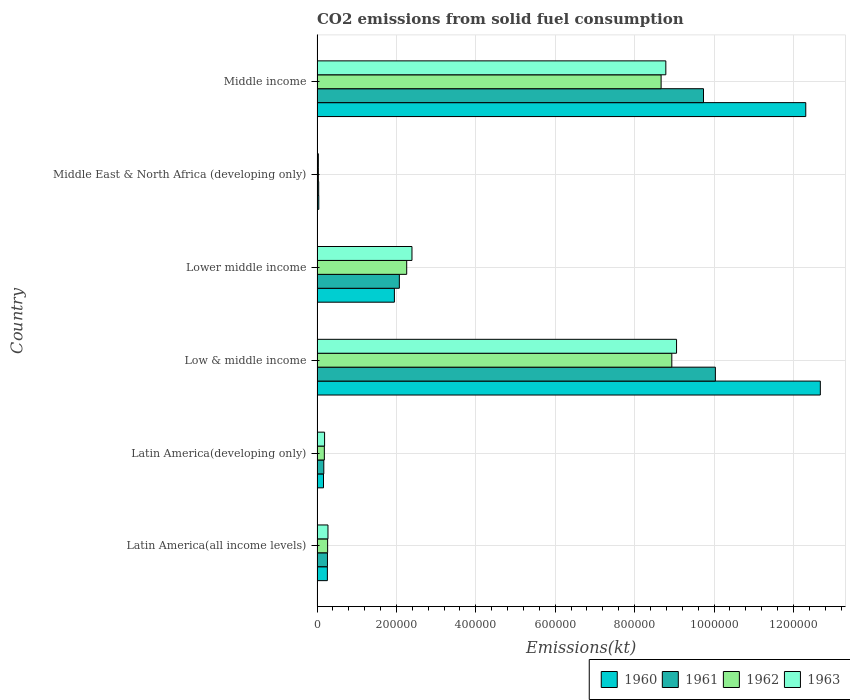Are the number of bars per tick equal to the number of legend labels?
Provide a succinct answer. Yes. Are the number of bars on each tick of the Y-axis equal?
Give a very brief answer. Yes. How many bars are there on the 5th tick from the top?
Keep it short and to the point. 4. How many bars are there on the 3rd tick from the bottom?
Provide a short and direct response. 4. What is the label of the 5th group of bars from the top?
Offer a terse response. Latin America(developing only). What is the amount of CO2 emitted in 1963 in Middle income?
Keep it short and to the point. 8.79e+05. Across all countries, what is the maximum amount of CO2 emitted in 1961?
Offer a terse response. 1.00e+06. Across all countries, what is the minimum amount of CO2 emitted in 1960?
Ensure brevity in your answer.  4356.8. In which country was the amount of CO2 emitted in 1962 maximum?
Make the answer very short. Low & middle income. In which country was the amount of CO2 emitted in 1962 minimum?
Your response must be concise. Middle East & North Africa (developing only). What is the total amount of CO2 emitted in 1960 in the graph?
Make the answer very short. 2.74e+06. What is the difference between the amount of CO2 emitted in 1960 in Low & middle income and that in Middle income?
Provide a short and direct response. 3.67e+04. What is the difference between the amount of CO2 emitted in 1961 in Latin America(developing only) and the amount of CO2 emitted in 1963 in Low & middle income?
Your answer should be compact. -8.89e+05. What is the average amount of CO2 emitted in 1961 per country?
Offer a terse response. 3.72e+05. What is the difference between the amount of CO2 emitted in 1961 and amount of CO2 emitted in 1963 in Middle East & North Africa (developing only)?
Keep it short and to the point. 800.71. What is the ratio of the amount of CO2 emitted in 1963 in Latin America(developing only) to that in Low & middle income?
Your answer should be very brief. 0.02. Is the amount of CO2 emitted in 1960 in Latin America(all income levels) less than that in Latin America(developing only)?
Offer a very short reply. No. Is the difference between the amount of CO2 emitted in 1961 in Latin America(all income levels) and Latin America(developing only) greater than the difference between the amount of CO2 emitted in 1963 in Latin America(all income levels) and Latin America(developing only)?
Your answer should be compact. Yes. What is the difference between the highest and the second highest amount of CO2 emitted in 1963?
Your response must be concise. 2.70e+04. What is the difference between the highest and the lowest amount of CO2 emitted in 1962?
Provide a short and direct response. 8.90e+05. What does the 4th bar from the top in Lower middle income represents?
Your answer should be very brief. 1960. What does the 4th bar from the bottom in Low & middle income represents?
Your response must be concise. 1963. Is it the case that in every country, the sum of the amount of CO2 emitted in 1963 and amount of CO2 emitted in 1961 is greater than the amount of CO2 emitted in 1960?
Give a very brief answer. Yes. Are the values on the major ticks of X-axis written in scientific E-notation?
Your answer should be very brief. No. Does the graph contain any zero values?
Provide a short and direct response. No. Does the graph contain grids?
Your answer should be compact. Yes. What is the title of the graph?
Give a very brief answer. CO2 emissions from solid fuel consumption. Does "2012" appear as one of the legend labels in the graph?
Ensure brevity in your answer.  No. What is the label or title of the X-axis?
Your answer should be very brief. Emissions(kt). What is the Emissions(kt) of 1960 in Latin America(all income levels)?
Your response must be concise. 2.60e+04. What is the Emissions(kt) in 1961 in Latin America(all income levels)?
Your answer should be very brief. 2.63e+04. What is the Emissions(kt) of 1962 in Latin America(all income levels)?
Give a very brief answer. 2.67e+04. What is the Emissions(kt) of 1963 in Latin America(all income levels)?
Ensure brevity in your answer.  2.75e+04. What is the Emissions(kt) in 1960 in Latin America(developing only)?
Offer a very short reply. 1.62e+04. What is the Emissions(kt) in 1961 in Latin America(developing only)?
Provide a succinct answer. 1.70e+04. What is the Emissions(kt) in 1962 in Latin America(developing only)?
Make the answer very short. 1.83e+04. What is the Emissions(kt) of 1963 in Latin America(developing only)?
Provide a short and direct response. 1.90e+04. What is the Emissions(kt) of 1960 in Low & middle income?
Offer a terse response. 1.27e+06. What is the Emissions(kt) in 1961 in Low & middle income?
Make the answer very short. 1.00e+06. What is the Emissions(kt) in 1962 in Low & middle income?
Provide a succinct answer. 8.94e+05. What is the Emissions(kt) of 1963 in Low & middle income?
Your answer should be compact. 9.06e+05. What is the Emissions(kt) of 1960 in Lower middle income?
Your response must be concise. 1.95e+05. What is the Emissions(kt) of 1961 in Lower middle income?
Provide a short and direct response. 2.07e+05. What is the Emissions(kt) of 1962 in Lower middle income?
Ensure brevity in your answer.  2.26e+05. What is the Emissions(kt) of 1963 in Lower middle income?
Ensure brevity in your answer.  2.39e+05. What is the Emissions(kt) in 1960 in Middle East & North Africa (developing only)?
Make the answer very short. 4356.8. What is the Emissions(kt) in 1961 in Middle East & North Africa (developing only)?
Your response must be concise. 4102.45. What is the Emissions(kt) of 1962 in Middle East & North Africa (developing only)?
Make the answer very short. 3311.16. What is the Emissions(kt) of 1963 in Middle East & North Africa (developing only)?
Give a very brief answer. 3301.74. What is the Emissions(kt) of 1960 in Middle income?
Keep it short and to the point. 1.23e+06. What is the Emissions(kt) of 1961 in Middle income?
Your answer should be compact. 9.74e+05. What is the Emissions(kt) in 1962 in Middle income?
Give a very brief answer. 8.67e+05. What is the Emissions(kt) of 1963 in Middle income?
Offer a terse response. 8.79e+05. Across all countries, what is the maximum Emissions(kt) in 1960?
Make the answer very short. 1.27e+06. Across all countries, what is the maximum Emissions(kt) of 1961?
Provide a succinct answer. 1.00e+06. Across all countries, what is the maximum Emissions(kt) in 1962?
Your answer should be very brief. 8.94e+05. Across all countries, what is the maximum Emissions(kt) in 1963?
Your answer should be very brief. 9.06e+05. Across all countries, what is the minimum Emissions(kt) of 1960?
Make the answer very short. 4356.8. Across all countries, what is the minimum Emissions(kt) in 1961?
Make the answer very short. 4102.45. Across all countries, what is the minimum Emissions(kt) in 1962?
Offer a terse response. 3311.16. Across all countries, what is the minimum Emissions(kt) in 1963?
Your answer should be very brief. 3301.74. What is the total Emissions(kt) of 1960 in the graph?
Provide a short and direct response. 2.74e+06. What is the total Emissions(kt) of 1961 in the graph?
Your answer should be very brief. 2.23e+06. What is the total Emissions(kt) in 1962 in the graph?
Your answer should be very brief. 2.03e+06. What is the total Emissions(kt) of 1963 in the graph?
Your answer should be very brief. 2.07e+06. What is the difference between the Emissions(kt) in 1960 in Latin America(all income levels) and that in Latin America(developing only)?
Your answer should be compact. 9759.8. What is the difference between the Emissions(kt) of 1961 in Latin America(all income levels) and that in Latin America(developing only)?
Make the answer very short. 9282.45. What is the difference between the Emissions(kt) of 1962 in Latin America(all income levels) and that in Latin America(developing only)?
Provide a succinct answer. 8301.83. What is the difference between the Emissions(kt) in 1963 in Latin America(all income levels) and that in Latin America(developing only)?
Give a very brief answer. 8542.91. What is the difference between the Emissions(kt) of 1960 in Latin America(all income levels) and that in Low & middle income?
Ensure brevity in your answer.  -1.24e+06. What is the difference between the Emissions(kt) in 1961 in Latin America(all income levels) and that in Low & middle income?
Offer a very short reply. -9.77e+05. What is the difference between the Emissions(kt) in 1962 in Latin America(all income levels) and that in Low & middle income?
Ensure brevity in your answer.  -8.67e+05. What is the difference between the Emissions(kt) of 1963 in Latin America(all income levels) and that in Low & middle income?
Your response must be concise. -8.78e+05. What is the difference between the Emissions(kt) of 1960 in Latin America(all income levels) and that in Lower middle income?
Offer a terse response. -1.69e+05. What is the difference between the Emissions(kt) of 1961 in Latin America(all income levels) and that in Lower middle income?
Your response must be concise. -1.81e+05. What is the difference between the Emissions(kt) of 1962 in Latin America(all income levels) and that in Lower middle income?
Your answer should be very brief. -1.99e+05. What is the difference between the Emissions(kt) of 1963 in Latin America(all income levels) and that in Lower middle income?
Provide a succinct answer. -2.12e+05. What is the difference between the Emissions(kt) in 1960 in Latin America(all income levels) and that in Middle East & North Africa (developing only)?
Provide a succinct answer. 2.17e+04. What is the difference between the Emissions(kt) in 1961 in Latin America(all income levels) and that in Middle East & North Africa (developing only)?
Your answer should be compact. 2.22e+04. What is the difference between the Emissions(kt) of 1962 in Latin America(all income levels) and that in Middle East & North Africa (developing only)?
Your response must be concise. 2.33e+04. What is the difference between the Emissions(kt) of 1963 in Latin America(all income levels) and that in Middle East & North Africa (developing only)?
Keep it short and to the point. 2.42e+04. What is the difference between the Emissions(kt) in 1960 in Latin America(all income levels) and that in Middle income?
Make the answer very short. -1.21e+06. What is the difference between the Emissions(kt) of 1961 in Latin America(all income levels) and that in Middle income?
Your answer should be very brief. -9.47e+05. What is the difference between the Emissions(kt) of 1962 in Latin America(all income levels) and that in Middle income?
Provide a short and direct response. -8.40e+05. What is the difference between the Emissions(kt) in 1963 in Latin America(all income levels) and that in Middle income?
Provide a short and direct response. -8.51e+05. What is the difference between the Emissions(kt) in 1960 in Latin America(developing only) and that in Low & middle income?
Offer a very short reply. -1.25e+06. What is the difference between the Emissions(kt) of 1961 in Latin America(developing only) and that in Low & middle income?
Offer a terse response. -9.86e+05. What is the difference between the Emissions(kt) of 1962 in Latin America(developing only) and that in Low & middle income?
Offer a terse response. -8.75e+05. What is the difference between the Emissions(kt) of 1963 in Latin America(developing only) and that in Low & middle income?
Offer a very short reply. -8.87e+05. What is the difference between the Emissions(kt) in 1960 in Latin America(developing only) and that in Lower middle income?
Keep it short and to the point. -1.79e+05. What is the difference between the Emissions(kt) in 1961 in Latin America(developing only) and that in Lower middle income?
Offer a very short reply. -1.90e+05. What is the difference between the Emissions(kt) in 1962 in Latin America(developing only) and that in Lower middle income?
Offer a very short reply. -2.08e+05. What is the difference between the Emissions(kt) in 1963 in Latin America(developing only) and that in Lower middle income?
Your response must be concise. -2.20e+05. What is the difference between the Emissions(kt) in 1960 in Latin America(developing only) and that in Middle East & North Africa (developing only)?
Ensure brevity in your answer.  1.19e+04. What is the difference between the Emissions(kt) in 1961 in Latin America(developing only) and that in Middle East & North Africa (developing only)?
Offer a very short reply. 1.29e+04. What is the difference between the Emissions(kt) in 1962 in Latin America(developing only) and that in Middle East & North Africa (developing only)?
Offer a very short reply. 1.50e+04. What is the difference between the Emissions(kt) in 1963 in Latin America(developing only) and that in Middle East & North Africa (developing only)?
Provide a short and direct response. 1.57e+04. What is the difference between the Emissions(kt) of 1960 in Latin America(developing only) and that in Middle income?
Keep it short and to the point. -1.21e+06. What is the difference between the Emissions(kt) of 1961 in Latin America(developing only) and that in Middle income?
Ensure brevity in your answer.  -9.57e+05. What is the difference between the Emissions(kt) of 1962 in Latin America(developing only) and that in Middle income?
Give a very brief answer. -8.48e+05. What is the difference between the Emissions(kt) in 1963 in Latin America(developing only) and that in Middle income?
Keep it short and to the point. -8.60e+05. What is the difference between the Emissions(kt) in 1960 in Low & middle income and that in Lower middle income?
Make the answer very short. 1.07e+06. What is the difference between the Emissions(kt) in 1961 in Low & middle income and that in Lower middle income?
Provide a short and direct response. 7.96e+05. What is the difference between the Emissions(kt) in 1962 in Low & middle income and that in Lower middle income?
Your answer should be very brief. 6.68e+05. What is the difference between the Emissions(kt) in 1963 in Low & middle income and that in Lower middle income?
Ensure brevity in your answer.  6.67e+05. What is the difference between the Emissions(kt) of 1960 in Low & middle income and that in Middle East & North Africa (developing only)?
Make the answer very short. 1.26e+06. What is the difference between the Emissions(kt) of 1961 in Low & middle income and that in Middle East & North Africa (developing only)?
Provide a short and direct response. 9.99e+05. What is the difference between the Emissions(kt) in 1962 in Low & middle income and that in Middle East & North Africa (developing only)?
Provide a short and direct response. 8.90e+05. What is the difference between the Emissions(kt) of 1963 in Low & middle income and that in Middle East & North Africa (developing only)?
Ensure brevity in your answer.  9.02e+05. What is the difference between the Emissions(kt) in 1960 in Low & middle income and that in Middle income?
Keep it short and to the point. 3.67e+04. What is the difference between the Emissions(kt) of 1961 in Low & middle income and that in Middle income?
Provide a succinct answer. 2.99e+04. What is the difference between the Emissions(kt) in 1962 in Low & middle income and that in Middle income?
Keep it short and to the point. 2.70e+04. What is the difference between the Emissions(kt) in 1963 in Low & middle income and that in Middle income?
Provide a short and direct response. 2.70e+04. What is the difference between the Emissions(kt) of 1960 in Lower middle income and that in Middle East & North Africa (developing only)?
Your response must be concise. 1.90e+05. What is the difference between the Emissions(kt) of 1961 in Lower middle income and that in Middle East & North Africa (developing only)?
Give a very brief answer. 2.03e+05. What is the difference between the Emissions(kt) in 1962 in Lower middle income and that in Middle East & North Africa (developing only)?
Provide a short and direct response. 2.23e+05. What is the difference between the Emissions(kt) in 1963 in Lower middle income and that in Middle East & North Africa (developing only)?
Keep it short and to the point. 2.36e+05. What is the difference between the Emissions(kt) of 1960 in Lower middle income and that in Middle income?
Your answer should be compact. -1.04e+06. What is the difference between the Emissions(kt) in 1961 in Lower middle income and that in Middle income?
Give a very brief answer. -7.66e+05. What is the difference between the Emissions(kt) in 1962 in Lower middle income and that in Middle income?
Provide a succinct answer. -6.41e+05. What is the difference between the Emissions(kt) in 1963 in Lower middle income and that in Middle income?
Your answer should be compact. -6.40e+05. What is the difference between the Emissions(kt) in 1960 in Middle East & North Africa (developing only) and that in Middle income?
Your answer should be very brief. -1.23e+06. What is the difference between the Emissions(kt) in 1961 in Middle East & North Africa (developing only) and that in Middle income?
Give a very brief answer. -9.69e+05. What is the difference between the Emissions(kt) of 1962 in Middle East & North Africa (developing only) and that in Middle income?
Ensure brevity in your answer.  -8.63e+05. What is the difference between the Emissions(kt) in 1963 in Middle East & North Africa (developing only) and that in Middle income?
Make the answer very short. -8.75e+05. What is the difference between the Emissions(kt) of 1960 in Latin America(all income levels) and the Emissions(kt) of 1961 in Latin America(developing only)?
Provide a short and direct response. 9031.46. What is the difference between the Emissions(kt) in 1960 in Latin America(all income levels) and the Emissions(kt) in 1962 in Latin America(developing only)?
Give a very brief answer. 7658.68. What is the difference between the Emissions(kt) in 1960 in Latin America(all income levels) and the Emissions(kt) in 1963 in Latin America(developing only)?
Provide a short and direct response. 7040.93. What is the difference between the Emissions(kt) of 1961 in Latin America(all income levels) and the Emissions(kt) of 1962 in Latin America(developing only)?
Make the answer very short. 7909.66. What is the difference between the Emissions(kt) of 1961 in Latin America(all income levels) and the Emissions(kt) of 1963 in Latin America(developing only)?
Your answer should be compact. 7291.91. What is the difference between the Emissions(kt) of 1962 in Latin America(all income levels) and the Emissions(kt) of 1963 in Latin America(developing only)?
Give a very brief answer. 7684.07. What is the difference between the Emissions(kt) in 1960 in Latin America(all income levels) and the Emissions(kt) in 1961 in Low & middle income?
Make the answer very short. -9.77e+05. What is the difference between the Emissions(kt) of 1960 in Latin America(all income levels) and the Emissions(kt) of 1962 in Low & middle income?
Your answer should be very brief. -8.68e+05. What is the difference between the Emissions(kt) in 1960 in Latin America(all income levels) and the Emissions(kt) in 1963 in Low & middle income?
Keep it short and to the point. -8.80e+05. What is the difference between the Emissions(kt) of 1961 in Latin America(all income levels) and the Emissions(kt) of 1962 in Low & middle income?
Ensure brevity in your answer.  -8.67e+05. What is the difference between the Emissions(kt) in 1961 in Latin America(all income levels) and the Emissions(kt) in 1963 in Low & middle income?
Give a very brief answer. -8.79e+05. What is the difference between the Emissions(kt) of 1962 in Latin America(all income levels) and the Emissions(kt) of 1963 in Low & middle income?
Provide a short and direct response. -8.79e+05. What is the difference between the Emissions(kt) in 1960 in Latin America(all income levels) and the Emissions(kt) in 1961 in Lower middle income?
Your answer should be compact. -1.81e+05. What is the difference between the Emissions(kt) of 1960 in Latin America(all income levels) and the Emissions(kt) of 1962 in Lower middle income?
Ensure brevity in your answer.  -2.00e+05. What is the difference between the Emissions(kt) of 1960 in Latin America(all income levels) and the Emissions(kt) of 1963 in Lower middle income?
Provide a succinct answer. -2.13e+05. What is the difference between the Emissions(kt) in 1961 in Latin America(all income levels) and the Emissions(kt) in 1962 in Lower middle income?
Ensure brevity in your answer.  -2.00e+05. What is the difference between the Emissions(kt) in 1961 in Latin America(all income levels) and the Emissions(kt) in 1963 in Lower middle income?
Give a very brief answer. -2.13e+05. What is the difference between the Emissions(kt) of 1962 in Latin America(all income levels) and the Emissions(kt) of 1963 in Lower middle income?
Ensure brevity in your answer.  -2.12e+05. What is the difference between the Emissions(kt) of 1960 in Latin America(all income levels) and the Emissions(kt) of 1961 in Middle East & North Africa (developing only)?
Your answer should be compact. 2.19e+04. What is the difference between the Emissions(kt) of 1960 in Latin America(all income levels) and the Emissions(kt) of 1962 in Middle East & North Africa (developing only)?
Provide a short and direct response. 2.27e+04. What is the difference between the Emissions(kt) in 1960 in Latin America(all income levels) and the Emissions(kt) in 1963 in Middle East & North Africa (developing only)?
Make the answer very short. 2.27e+04. What is the difference between the Emissions(kt) of 1961 in Latin America(all income levels) and the Emissions(kt) of 1962 in Middle East & North Africa (developing only)?
Provide a short and direct response. 2.29e+04. What is the difference between the Emissions(kt) in 1961 in Latin America(all income levels) and the Emissions(kt) in 1963 in Middle East & North Africa (developing only)?
Provide a short and direct response. 2.30e+04. What is the difference between the Emissions(kt) of 1962 in Latin America(all income levels) and the Emissions(kt) of 1963 in Middle East & North Africa (developing only)?
Offer a very short reply. 2.33e+04. What is the difference between the Emissions(kt) of 1960 in Latin America(all income levels) and the Emissions(kt) of 1961 in Middle income?
Provide a short and direct response. -9.47e+05. What is the difference between the Emissions(kt) of 1960 in Latin America(all income levels) and the Emissions(kt) of 1962 in Middle income?
Offer a very short reply. -8.41e+05. What is the difference between the Emissions(kt) in 1960 in Latin America(all income levels) and the Emissions(kt) in 1963 in Middle income?
Your answer should be very brief. -8.53e+05. What is the difference between the Emissions(kt) in 1961 in Latin America(all income levels) and the Emissions(kt) in 1962 in Middle income?
Give a very brief answer. -8.40e+05. What is the difference between the Emissions(kt) of 1961 in Latin America(all income levels) and the Emissions(kt) of 1963 in Middle income?
Your response must be concise. -8.52e+05. What is the difference between the Emissions(kt) of 1962 in Latin America(all income levels) and the Emissions(kt) of 1963 in Middle income?
Provide a succinct answer. -8.52e+05. What is the difference between the Emissions(kt) of 1960 in Latin America(developing only) and the Emissions(kt) of 1961 in Low & middle income?
Your answer should be compact. -9.87e+05. What is the difference between the Emissions(kt) of 1960 in Latin America(developing only) and the Emissions(kt) of 1962 in Low & middle income?
Make the answer very short. -8.77e+05. What is the difference between the Emissions(kt) in 1960 in Latin America(developing only) and the Emissions(kt) in 1963 in Low & middle income?
Offer a terse response. -8.89e+05. What is the difference between the Emissions(kt) in 1961 in Latin America(developing only) and the Emissions(kt) in 1962 in Low & middle income?
Make the answer very short. -8.77e+05. What is the difference between the Emissions(kt) in 1961 in Latin America(developing only) and the Emissions(kt) in 1963 in Low & middle income?
Make the answer very short. -8.89e+05. What is the difference between the Emissions(kt) of 1962 in Latin America(developing only) and the Emissions(kt) of 1963 in Low & middle income?
Ensure brevity in your answer.  -8.87e+05. What is the difference between the Emissions(kt) in 1960 in Latin America(developing only) and the Emissions(kt) in 1961 in Lower middle income?
Keep it short and to the point. -1.91e+05. What is the difference between the Emissions(kt) in 1960 in Latin America(developing only) and the Emissions(kt) in 1962 in Lower middle income?
Your answer should be compact. -2.10e+05. What is the difference between the Emissions(kt) of 1960 in Latin America(developing only) and the Emissions(kt) of 1963 in Lower middle income?
Offer a terse response. -2.23e+05. What is the difference between the Emissions(kt) of 1961 in Latin America(developing only) and the Emissions(kt) of 1962 in Lower middle income?
Make the answer very short. -2.09e+05. What is the difference between the Emissions(kt) in 1961 in Latin America(developing only) and the Emissions(kt) in 1963 in Lower middle income?
Keep it short and to the point. -2.22e+05. What is the difference between the Emissions(kt) in 1962 in Latin America(developing only) and the Emissions(kt) in 1963 in Lower middle income?
Keep it short and to the point. -2.21e+05. What is the difference between the Emissions(kt) of 1960 in Latin America(developing only) and the Emissions(kt) of 1961 in Middle East & North Africa (developing only)?
Your answer should be compact. 1.21e+04. What is the difference between the Emissions(kt) in 1960 in Latin America(developing only) and the Emissions(kt) in 1962 in Middle East & North Africa (developing only)?
Your response must be concise. 1.29e+04. What is the difference between the Emissions(kt) in 1960 in Latin America(developing only) and the Emissions(kt) in 1963 in Middle East & North Africa (developing only)?
Provide a succinct answer. 1.29e+04. What is the difference between the Emissions(kt) in 1961 in Latin America(developing only) and the Emissions(kt) in 1962 in Middle East & North Africa (developing only)?
Keep it short and to the point. 1.37e+04. What is the difference between the Emissions(kt) in 1961 in Latin America(developing only) and the Emissions(kt) in 1963 in Middle East & North Africa (developing only)?
Provide a short and direct response. 1.37e+04. What is the difference between the Emissions(kt) of 1962 in Latin America(developing only) and the Emissions(kt) of 1963 in Middle East & North Africa (developing only)?
Keep it short and to the point. 1.50e+04. What is the difference between the Emissions(kt) in 1960 in Latin America(developing only) and the Emissions(kt) in 1961 in Middle income?
Make the answer very short. -9.57e+05. What is the difference between the Emissions(kt) in 1960 in Latin America(developing only) and the Emissions(kt) in 1962 in Middle income?
Your answer should be compact. -8.50e+05. What is the difference between the Emissions(kt) in 1960 in Latin America(developing only) and the Emissions(kt) in 1963 in Middle income?
Offer a terse response. -8.62e+05. What is the difference between the Emissions(kt) in 1961 in Latin America(developing only) and the Emissions(kt) in 1962 in Middle income?
Give a very brief answer. -8.50e+05. What is the difference between the Emissions(kt) in 1961 in Latin America(developing only) and the Emissions(kt) in 1963 in Middle income?
Provide a short and direct response. -8.62e+05. What is the difference between the Emissions(kt) of 1962 in Latin America(developing only) and the Emissions(kt) of 1963 in Middle income?
Give a very brief answer. -8.60e+05. What is the difference between the Emissions(kt) of 1960 in Low & middle income and the Emissions(kt) of 1961 in Lower middle income?
Provide a succinct answer. 1.06e+06. What is the difference between the Emissions(kt) in 1960 in Low & middle income and the Emissions(kt) in 1962 in Lower middle income?
Your answer should be compact. 1.04e+06. What is the difference between the Emissions(kt) in 1960 in Low & middle income and the Emissions(kt) in 1963 in Lower middle income?
Your response must be concise. 1.03e+06. What is the difference between the Emissions(kt) in 1961 in Low & middle income and the Emissions(kt) in 1962 in Lower middle income?
Your answer should be very brief. 7.78e+05. What is the difference between the Emissions(kt) of 1961 in Low & middle income and the Emissions(kt) of 1963 in Lower middle income?
Offer a very short reply. 7.64e+05. What is the difference between the Emissions(kt) in 1962 in Low & middle income and the Emissions(kt) in 1963 in Lower middle income?
Your answer should be very brief. 6.55e+05. What is the difference between the Emissions(kt) of 1960 in Low & middle income and the Emissions(kt) of 1961 in Middle East & North Africa (developing only)?
Provide a short and direct response. 1.26e+06. What is the difference between the Emissions(kt) of 1960 in Low & middle income and the Emissions(kt) of 1962 in Middle East & North Africa (developing only)?
Offer a terse response. 1.26e+06. What is the difference between the Emissions(kt) of 1960 in Low & middle income and the Emissions(kt) of 1963 in Middle East & North Africa (developing only)?
Keep it short and to the point. 1.26e+06. What is the difference between the Emissions(kt) in 1961 in Low & middle income and the Emissions(kt) in 1962 in Middle East & North Africa (developing only)?
Give a very brief answer. 1.00e+06. What is the difference between the Emissions(kt) in 1961 in Low & middle income and the Emissions(kt) in 1963 in Middle East & North Africa (developing only)?
Provide a succinct answer. 1.00e+06. What is the difference between the Emissions(kt) in 1962 in Low & middle income and the Emissions(kt) in 1963 in Middle East & North Africa (developing only)?
Ensure brevity in your answer.  8.90e+05. What is the difference between the Emissions(kt) in 1960 in Low & middle income and the Emissions(kt) in 1961 in Middle income?
Provide a succinct answer. 2.94e+05. What is the difference between the Emissions(kt) of 1960 in Low & middle income and the Emissions(kt) of 1962 in Middle income?
Provide a succinct answer. 4.01e+05. What is the difference between the Emissions(kt) of 1960 in Low & middle income and the Emissions(kt) of 1963 in Middle income?
Ensure brevity in your answer.  3.89e+05. What is the difference between the Emissions(kt) in 1961 in Low & middle income and the Emissions(kt) in 1962 in Middle income?
Offer a very short reply. 1.37e+05. What is the difference between the Emissions(kt) of 1961 in Low & middle income and the Emissions(kt) of 1963 in Middle income?
Your response must be concise. 1.25e+05. What is the difference between the Emissions(kt) of 1962 in Low & middle income and the Emissions(kt) of 1963 in Middle income?
Provide a succinct answer. 1.51e+04. What is the difference between the Emissions(kt) in 1960 in Lower middle income and the Emissions(kt) in 1961 in Middle East & North Africa (developing only)?
Your answer should be compact. 1.91e+05. What is the difference between the Emissions(kt) of 1960 in Lower middle income and the Emissions(kt) of 1962 in Middle East & North Africa (developing only)?
Ensure brevity in your answer.  1.91e+05. What is the difference between the Emissions(kt) in 1960 in Lower middle income and the Emissions(kt) in 1963 in Middle East & North Africa (developing only)?
Provide a succinct answer. 1.92e+05. What is the difference between the Emissions(kt) in 1961 in Lower middle income and the Emissions(kt) in 1962 in Middle East & North Africa (developing only)?
Keep it short and to the point. 2.04e+05. What is the difference between the Emissions(kt) of 1961 in Lower middle income and the Emissions(kt) of 1963 in Middle East & North Africa (developing only)?
Give a very brief answer. 2.04e+05. What is the difference between the Emissions(kt) of 1962 in Lower middle income and the Emissions(kt) of 1963 in Middle East & North Africa (developing only)?
Offer a very short reply. 2.23e+05. What is the difference between the Emissions(kt) in 1960 in Lower middle income and the Emissions(kt) in 1961 in Middle income?
Offer a terse response. -7.79e+05. What is the difference between the Emissions(kt) in 1960 in Lower middle income and the Emissions(kt) in 1962 in Middle income?
Offer a very short reply. -6.72e+05. What is the difference between the Emissions(kt) of 1960 in Lower middle income and the Emissions(kt) of 1963 in Middle income?
Offer a very short reply. -6.84e+05. What is the difference between the Emissions(kt) of 1961 in Lower middle income and the Emissions(kt) of 1962 in Middle income?
Provide a short and direct response. -6.59e+05. What is the difference between the Emissions(kt) of 1961 in Lower middle income and the Emissions(kt) of 1963 in Middle income?
Provide a short and direct response. -6.71e+05. What is the difference between the Emissions(kt) in 1962 in Lower middle income and the Emissions(kt) in 1963 in Middle income?
Offer a terse response. -6.53e+05. What is the difference between the Emissions(kt) in 1960 in Middle East & North Africa (developing only) and the Emissions(kt) in 1961 in Middle income?
Provide a succinct answer. -9.69e+05. What is the difference between the Emissions(kt) of 1960 in Middle East & North Africa (developing only) and the Emissions(kt) of 1962 in Middle income?
Make the answer very short. -8.62e+05. What is the difference between the Emissions(kt) in 1960 in Middle East & North Africa (developing only) and the Emissions(kt) in 1963 in Middle income?
Your answer should be compact. -8.74e+05. What is the difference between the Emissions(kt) in 1961 in Middle East & North Africa (developing only) and the Emissions(kt) in 1962 in Middle income?
Your response must be concise. -8.63e+05. What is the difference between the Emissions(kt) of 1961 in Middle East & North Africa (developing only) and the Emissions(kt) of 1963 in Middle income?
Offer a very short reply. -8.75e+05. What is the difference between the Emissions(kt) in 1962 in Middle East & North Africa (developing only) and the Emissions(kt) in 1963 in Middle income?
Your answer should be compact. -8.75e+05. What is the average Emissions(kt) in 1960 per country?
Provide a short and direct response. 4.57e+05. What is the average Emissions(kt) in 1961 per country?
Provide a succinct answer. 3.72e+05. What is the average Emissions(kt) in 1962 per country?
Offer a very short reply. 3.39e+05. What is the average Emissions(kt) in 1963 per country?
Provide a succinct answer. 3.46e+05. What is the difference between the Emissions(kt) in 1960 and Emissions(kt) in 1961 in Latin America(all income levels)?
Make the answer very short. -250.98. What is the difference between the Emissions(kt) in 1960 and Emissions(kt) in 1962 in Latin America(all income levels)?
Ensure brevity in your answer.  -643.15. What is the difference between the Emissions(kt) in 1960 and Emissions(kt) in 1963 in Latin America(all income levels)?
Keep it short and to the point. -1501.98. What is the difference between the Emissions(kt) of 1961 and Emissions(kt) of 1962 in Latin America(all income levels)?
Keep it short and to the point. -392.16. What is the difference between the Emissions(kt) in 1961 and Emissions(kt) in 1963 in Latin America(all income levels)?
Ensure brevity in your answer.  -1251. What is the difference between the Emissions(kt) in 1962 and Emissions(kt) in 1963 in Latin America(all income levels)?
Offer a very short reply. -858.84. What is the difference between the Emissions(kt) of 1960 and Emissions(kt) of 1961 in Latin America(developing only)?
Offer a terse response. -728.34. What is the difference between the Emissions(kt) of 1960 and Emissions(kt) of 1962 in Latin America(developing only)?
Make the answer very short. -2101.12. What is the difference between the Emissions(kt) of 1960 and Emissions(kt) of 1963 in Latin America(developing only)?
Make the answer very short. -2718.88. What is the difference between the Emissions(kt) in 1961 and Emissions(kt) in 1962 in Latin America(developing only)?
Keep it short and to the point. -1372.79. What is the difference between the Emissions(kt) in 1961 and Emissions(kt) in 1963 in Latin America(developing only)?
Ensure brevity in your answer.  -1990.54. What is the difference between the Emissions(kt) in 1962 and Emissions(kt) in 1963 in Latin America(developing only)?
Ensure brevity in your answer.  -617.75. What is the difference between the Emissions(kt) in 1960 and Emissions(kt) in 1961 in Low & middle income?
Keep it short and to the point. 2.64e+05. What is the difference between the Emissions(kt) in 1960 and Emissions(kt) in 1962 in Low & middle income?
Keep it short and to the point. 3.74e+05. What is the difference between the Emissions(kt) in 1960 and Emissions(kt) in 1963 in Low & middle income?
Your response must be concise. 3.62e+05. What is the difference between the Emissions(kt) of 1961 and Emissions(kt) of 1962 in Low & middle income?
Make the answer very short. 1.10e+05. What is the difference between the Emissions(kt) in 1961 and Emissions(kt) in 1963 in Low & middle income?
Provide a short and direct response. 9.78e+04. What is the difference between the Emissions(kt) in 1962 and Emissions(kt) in 1963 in Low & middle income?
Your answer should be compact. -1.20e+04. What is the difference between the Emissions(kt) of 1960 and Emissions(kt) of 1961 in Lower middle income?
Give a very brief answer. -1.25e+04. What is the difference between the Emissions(kt) in 1960 and Emissions(kt) in 1962 in Lower middle income?
Make the answer very short. -3.10e+04. What is the difference between the Emissions(kt) of 1960 and Emissions(kt) of 1963 in Lower middle income?
Offer a very short reply. -4.43e+04. What is the difference between the Emissions(kt) of 1961 and Emissions(kt) of 1962 in Lower middle income?
Offer a very short reply. -1.86e+04. What is the difference between the Emissions(kt) in 1961 and Emissions(kt) in 1963 in Lower middle income?
Make the answer very short. -3.18e+04. What is the difference between the Emissions(kt) of 1962 and Emissions(kt) of 1963 in Lower middle income?
Make the answer very short. -1.32e+04. What is the difference between the Emissions(kt) of 1960 and Emissions(kt) of 1961 in Middle East & North Africa (developing only)?
Give a very brief answer. 254.34. What is the difference between the Emissions(kt) of 1960 and Emissions(kt) of 1962 in Middle East & North Africa (developing only)?
Keep it short and to the point. 1045.63. What is the difference between the Emissions(kt) of 1960 and Emissions(kt) of 1963 in Middle East & North Africa (developing only)?
Your response must be concise. 1055.05. What is the difference between the Emissions(kt) in 1961 and Emissions(kt) in 1962 in Middle East & North Africa (developing only)?
Give a very brief answer. 791.29. What is the difference between the Emissions(kt) of 1961 and Emissions(kt) of 1963 in Middle East & North Africa (developing only)?
Offer a terse response. 800.71. What is the difference between the Emissions(kt) in 1962 and Emissions(kt) in 1963 in Middle East & North Africa (developing only)?
Give a very brief answer. 9.42. What is the difference between the Emissions(kt) in 1960 and Emissions(kt) in 1961 in Middle income?
Provide a succinct answer. 2.58e+05. What is the difference between the Emissions(kt) in 1960 and Emissions(kt) in 1962 in Middle income?
Ensure brevity in your answer.  3.64e+05. What is the difference between the Emissions(kt) of 1960 and Emissions(kt) of 1963 in Middle income?
Offer a terse response. 3.53e+05. What is the difference between the Emissions(kt) of 1961 and Emissions(kt) of 1962 in Middle income?
Your response must be concise. 1.07e+05. What is the difference between the Emissions(kt) in 1961 and Emissions(kt) in 1963 in Middle income?
Provide a short and direct response. 9.49e+04. What is the difference between the Emissions(kt) in 1962 and Emissions(kt) in 1963 in Middle income?
Offer a terse response. -1.19e+04. What is the ratio of the Emissions(kt) of 1960 in Latin America(all income levels) to that in Latin America(developing only)?
Your answer should be very brief. 1.6. What is the ratio of the Emissions(kt) in 1961 in Latin America(all income levels) to that in Latin America(developing only)?
Keep it short and to the point. 1.55. What is the ratio of the Emissions(kt) of 1962 in Latin America(all income levels) to that in Latin America(developing only)?
Give a very brief answer. 1.45. What is the ratio of the Emissions(kt) in 1963 in Latin America(all income levels) to that in Latin America(developing only)?
Provide a succinct answer. 1.45. What is the ratio of the Emissions(kt) in 1960 in Latin America(all income levels) to that in Low & middle income?
Ensure brevity in your answer.  0.02. What is the ratio of the Emissions(kt) in 1961 in Latin America(all income levels) to that in Low & middle income?
Give a very brief answer. 0.03. What is the ratio of the Emissions(kt) of 1962 in Latin America(all income levels) to that in Low & middle income?
Your response must be concise. 0.03. What is the ratio of the Emissions(kt) in 1963 in Latin America(all income levels) to that in Low & middle income?
Give a very brief answer. 0.03. What is the ratio of the Emissions(kt) in 1960 in Latin America(all income levels) to that in Lower middle income?
Your response must be concise. 0.13. What is the ratio of the Emissions(kt) of 1961 in Latin America(all income levels) to that in Lower middle income?
Make the answer very short. 0.13. What is the ratio of the Emissions(kt) of 1962 in Latin America(all income levels) to that in Lower middle income?
Keep it short and to the point. 0.12. What is the ratio of the Emissions(kt) of 1963 in Latin America(all income levels) to that in Lower middle income?
Keep it short and to the point. 0.12. What is the ratio of the Emissions(kt) in 1960 in Latin America(all income levels) to that in Middle East & North Africa (developing only)?
Give a very brief answer. 5.97. What is the ratio of the Emissions(kt) in 1961 in Latin America(all income levels) to that in Middle East & North Africa (developing only)?
Give a very brief answer. 6.4. What is the ratio of the Emissions(kt) of 1962 in Latin America(all income levels) to that in Middle East & North Africa (developing only)?
Give a very brief answer. 8.05. What is the ratio of the Emissions(kt) in 1963 in Latin America(all income levels) to that in Middle East & North Africa (developing only)?
Your answer should be very brief. 8.33. What is the ratio of the Emissions(kt) in 1960 in Latin America(all income levels) to that in Middle income?
Ensure brevity in your answer.  0.02. What is the ratio of the Emissions(kt) in 1961 in Latin America(all income levels) to that in Middle income?
Your response must be concise. 0.03. What is the ratio of the Emissions(kt) of 1962 in Latin America(all income levels) to that in Middle income?
Ensure brevity in your answer.  0.03. What is the ratio of the Emissions(kt) in 1963 in Latin America(all income levels) to that in Middle income?
Ensure brevity in your answer.  0.03. What is the ratio of the Emissions(kt) in 1960 in Latin America(developing only) to that in Low & middle income?
Make the answer very short. 0.01. What is the ratio of the Emissions(kt) in 1961 in Latin America(developing only) to that in Low & middle income?
Make the answer very short. 0.02. What is the ratio of the Emissions(kt) in 1962 in Latin America(developing only) to that in Low & middle income?
Provide a short and direct response. 0.02. What is the ratio of the Emissions(kt) in 1963 in Latin America(developing only) to that in Low & middle income?
Provide a succinct answer. 0.02. What is the ratio of the Emissions(kt) in 1960 in Latin America(developing only) to that in Lower middle income?
Make the answer very short. 0.08. What is the ratio of the Emissions(kt) of 1961 in Latin America(developing only) to that in Lower middle income?
Your answer should be compact. 0.08. What is the ratio of the Emissions(kt) of 1962 in Latin America(developing only) to that in Lower middle income?
Your answer should be compact. 0.08. What is the ratio of the Emissions(kt) of 1963 in Latin America(developing only) to that in Lower middle income?
Provide a short and direct response. 0.08. What is the ratio of the Emissions(kt) in 1960 in Latin America(developing only) to that in Middle East & North Africa (developing only)?
Keep it short and to the point. 3.73. What is the ratio of the Emissions(kt) in 1961 in Latin America(developing only) to that in Middle East & North Africa (developing only)?
Your response must be concise. 4.14. What is the ratio of the Emissions(kt) in 1962 in Latin America(developing only) to that in Middle East & North Africa (developing only)?
Your response must be concise. 5.54. What is the ratio of the Emissions(kt) in 1963 in Latin America(developing only) to that in Middle East & North Africa (developing only)?
Make the answer very short. 5.74. What is the ratio of the Emissions(kt) in 1960 in Latin America(developing only) to that in Middle income?
Provide a short and direct response. 0.01. What is the ratio of the Emissions(kt) of 1961 in Latin America(developing only) to that in Middle income?
Provide a short and direct response. 0.02. What is the ratio of the Emissions(kt) in 1962 in Latin America(developing only) to that in Middle income?
Give a very brief answer. 0.02. What is the ratio of the Emissions(kt) of 1963 in Latin America(developing only) to that in Middle income?
Ensure brevity in your answer.  0.02. What is the ratio of the Emissions(kt) in 1960 in Low & middle income to that in Lower middle income?
Provide a short and direct response. 6.51. What is the ratio of the Emissions(kt) in 1961 in Low & middle income to that in Lower middle income?
Provide a succinct answer. 4.84. What is the ratio of the Emissions(kt) in 1962 in Low & middle income to that in Lower middle income?
Your answer should be very brief. 3.96. What is the ratio of the Emissions(kt) in 1963 in Low & middle income to that in Lower middle income?
Your answer should be very brief. 3.79. What is the ratio of the Emissions(kt) in 1960 in Low & middle income to that in Middle East & North Africa (developing only)?
Make the answer very short. 291. What is the ratio of the Emissions(kt) of 1961 in Low & middle income to that in Middle East & North Africa (developing only)?
Ensure brevity in your answer.  244.6. What is the ratio of the Emissions(kt) of 1962 in Low & middle income to that in Middle East & North Africa (developing only)?
Provide a short and direct response. 269.9. What is the ratio of the Emissions(kt) of 1963 in Low & middle income to that in Middle East & North Africa (developing only)?
Keep it short and to the point. 274.29. What is the ratio of the Emissions(kt) of 1960 in Low & middle income to that in Middle income?
Provide a succinct answer. 1.03. What is the ratio of the Emissions(kt) of 1961 in Low & middle income to that in Middle income?
Provide a short and direct response. 1.03. What is the ratio of the Emissions(kt) in 1962 in Low & middle income to that in Middle income?
Your answer should be compact. 1.03. What is the ratio of the Emissions(kt) in 1963 in Low & middle income to that in Middle income?
Make the answer very short. 1.03. What is the ratio of the Emissions(kt) of 1960 in Lower middle income to that in Middle East & North Africa (developing only)?
Provide a short and direct response. 44.71. What is the ratio of the Emissions(kt) of 1961 in Lower middle income to that in Middle East & North Africa (developing only)?
Provide a short and direct response. 50.53. What is the ratio of the Emissions(kt) of 1962 in Lower middle income to that in Middle East & North Africa (developing only)?
Provide a succinct answer. 68.21. What is the ratio of the Emissions(kt) in 1963 in Lower middle income to that in Middle East & North Africa (developing only)?
Provide a short and direct response. 72.42. What is the ratio of the Emissions(kt) of 1960 in Lower middle income to that in Middle income?
Give a very brief answer. 0.16. What is the ratio of the Emissions(kt) of 1961 in Lower middle income to that in Middle income?
Offer a terse response. 0.21. What is the ratio of the Emissions(kt) of 1962 in Lower middle income to that in Middle income?
Your answer should be compact. 0.26. What is the ratio of the Emissions(kt) of 1963 in Lower middle income to that in Middle income?
Ensure brevity in your answer.  0.27. What is the ratio of the Emissions(kt) in 1960 in Middle East & North Africa (developing only) to that in Middle income?
Keep it short and to the point. 0. What is the ratio of the Emissions(kt) in 1961 in Middle East & North Africa (developing only) to that in Middle income?
Make the answer very short. 0. What is the ratio of the Emissions(kt) of 1962 in Middle East & North Africa (developing only) to that in Middle income?
Provide a succinct answer. 0. What is the ratio of the Emissions(kt) in 1963 in Middle East & North Africa (developing only) to that in Middle income?
Offer a terse response. 0. What is the difference between the highest and the second highest Emissions(kt) in 1960?
Ensure brevity in your answer.  3.67e+04. What is the difference between the highest and the second highest Emissions(kt) of 1961?
Ensure brevity in your answer.  2.99e+04. What is the difference between the highest and the second highest Emissions(kt) in 1962?
Your answer should be compact. 2.70e+04. What is the difference between the highest and the second highest Emissions(kt) in 1963?
Provide a short and direct response. 2.70e+04. What is the difference between the highest and the lowest Emissions(kt) of 1960?
Your response must be concise. 1.26e+06. What is the difference between the highest and the lowest Emissions(kt) in 1961?
Give a very brief answer. 9.99e+05. What is the difference between the highest and the lowest Emissions(kt) in 1962?
Your response must be concise. 8.90e+05. What is the difference between the highest and the lowest Emissions(kt) in 1963?
Make the answer very short. 9.02e+05. 